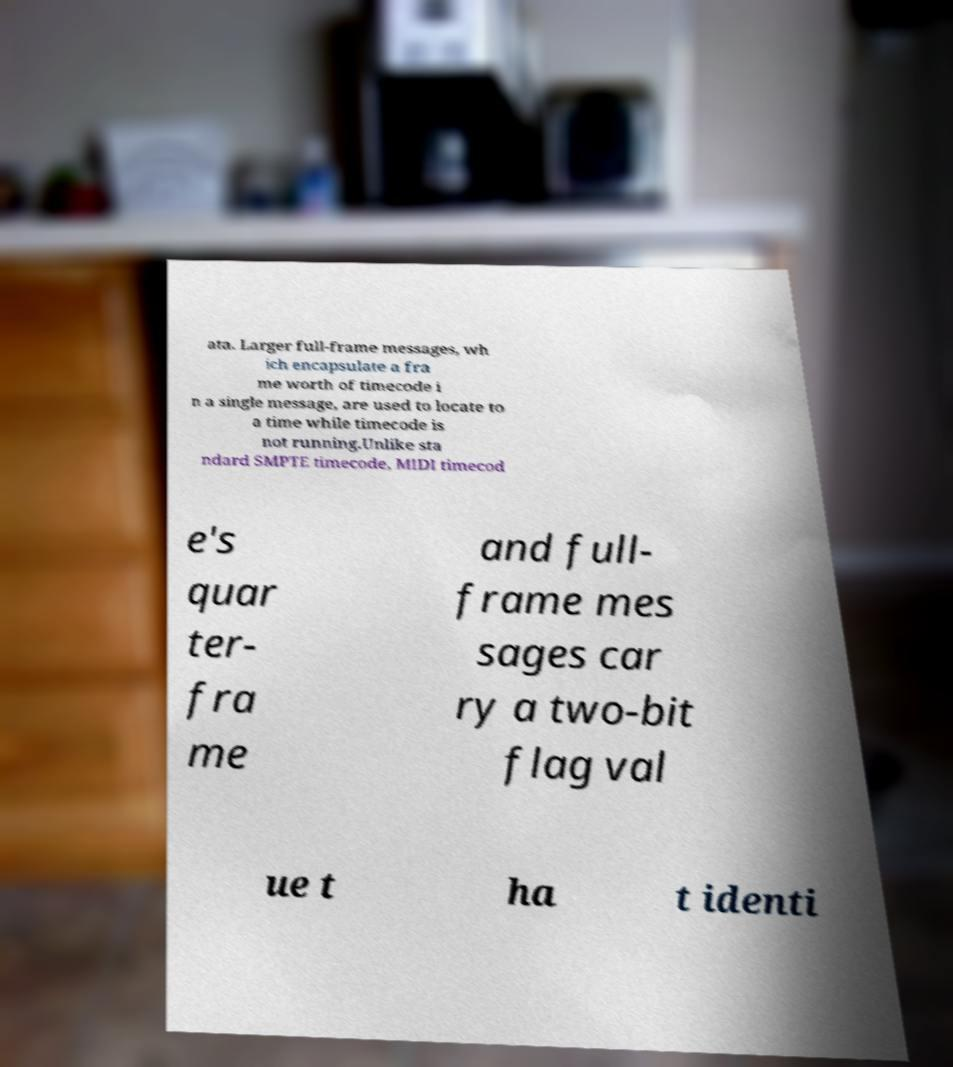Please read and relay the text visible in this image. What does it say? ata. Larger full-frame messages, wh ich encapsulate a fra me worth of timecode i n a single message, are used to locate to a time while timecode is not running.Unlike sta ndard SMPTE timecode, MIDI timecod e's quar ter- fra me and full- frame mes sages car ry a two-bit flag val ue t ha t identi 